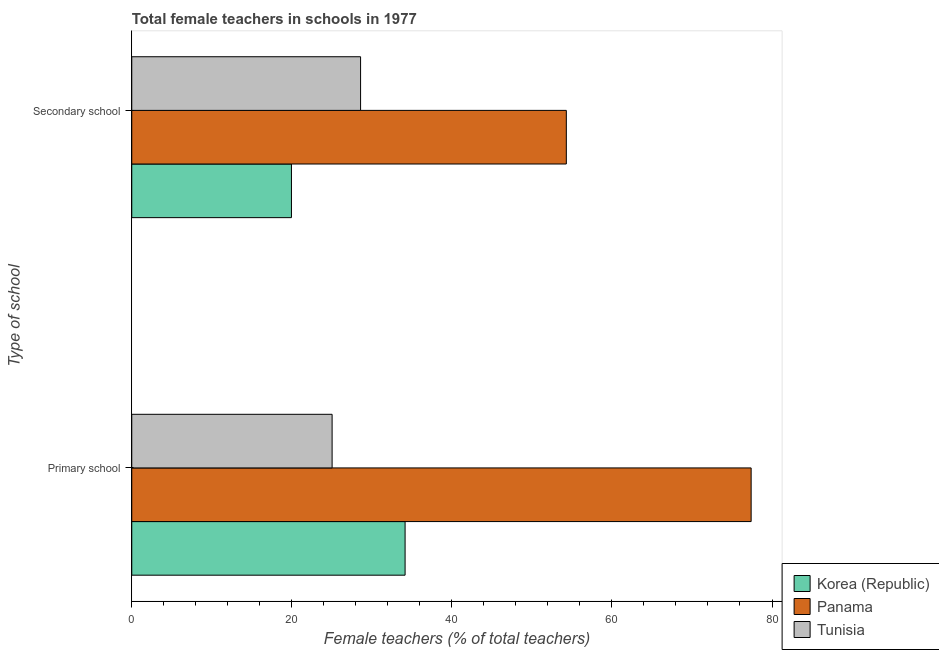How many groups of bars are there?
Provide a short and direct response. 2. Are the number of bars per tick equal to the number of legend labels?
Ensure brevity in your answer.  Yes. What is the label of the 2nd group of bars from the top?
Ensure brevity in your answer.  Primary school. What is the percentage of female teachers in primary schools in Tunisia?
Ensure brevity in your answer.  25.03. Across all countries, what is the maximum percentage of female teachers in primary schools?
Offer a very short reply. 77.39. Across all countries, what is the minimum percentage of female teachers in primary schools?
Ensure brevity in your answer.  25.03. In which country was the percentage of female teachers in primary schools maximum?
Provide a succinct answer. Panama. In which country was the percentage of female teachers in primary schools minimum?
Your response must be concise. Tunisia. What is the total percentage of female teachers in primary schools in the graph?
Your response must be concise. 136.58. What is the difference between the percentage of female teachers in secondary schools in Tunisia and that in Panama?
Keep it short and to the point. -25.71. What is the difference between the percentage of female teachers in secondary schools in Tunisia and the percentage of female teachers in primary schools in Korea (Republic)?
Your response must be concise. -5.56. What is the average percentage of female teachers in primary schools per country?
Ensure brevity in your answer.  45.53. What is the difference between the percentage of female teachers in primary schools and percentage of female teachers in secondary schools in Tunisia?
Ensure brevity in your answer.  -3.56. In how many countries, is the percentage of female teachers in primary schools greater than 8 %?
Make the answer very short. 3. What is the ratio of the percentage of female teachers in secondary schools in Tunisia to that in Korea (Republic)?
Make the answer very short. 1.43. In how many countries, is the percentage of female teachers in secondary schools greater than the average percentage of female teachers in secondary schools taken over all countries?
Provide a short and direct response. 1. What does the 1st bar from the bottom in Primary school represents?
Offer a very short reply. Korea (Republic). What is the difference between two consecutive major ticks on the X-axis?
Keep it short and to the point. 20. Are the values on the major ticks of X-axis written in scientific E-notation?
Give a very brief answer. No. Does the graph contain any zero values?
Ensure brevity in your answer.  No. Does the graph contain grids?
Provide a short and direct response. No. Where does the legend appear in the graph?
Your answer should be very brief. Bottom right. How many legend labels are there?
Ensure brevity in your answer.  3. How are the legend labels stacked?
Offer a very short reply. Vertical. What is the title of the graph?
Your answer should be compact. Total female teachers in schools in 1977. What is the label or title of the X-axis?
Ensure brevity in your answer.  Female teachers (% of total teachers). What is the label or title of the Y-axis?
Provide a short and direct response. Type of school. What is the Female teachers (% of total teachers) of Korea (Republic) in Primary school?
Offer a very short reply. 34.15. What is the Female teachers (% of total teachers) in Panama in Primary school?
Offer a very short reply. 77.39. What is the Female teachers (% of total teachers) in Tunisia in Primary school?
Provide a succinct answer. 25.03. What is the Female teachers (% of total teachers) of Korea (Republic) in Secondary school?
Give a very brief answer. 19.95. What is the Female teachers (% of total teachers) in Panama in Secondary school?
Keep it short and to the point. 54.3. What is the Female teachers (% of total teachers) in Tunisia in Secondary school?
Give a very brief answer. 28.59. Across all Type of school, what is the maximum Female teachers (% of total teachers) of Korea (Republic)?
Offer a very short reply. 34.15. Across all Type of school, what is the maximum Female teachers (% of total teachers) of Panama?
Your answer should be very brief. 77.39. Across all Type of school, what is the maximum Female teachers (% of total teachers) of Tunisia?
Your answer should be very brief. 28.59. Across all Type of school, what is the minimum Female teachers (% of total teachers) in Korea (Republic)?
Keep it short and to the point. 19.95. Across all Type of school, what is the minimum Female teachers (% of total teachers) of Panama?
Ensure brevity in your answer.  54.3. Across all Type of school, what is the minimum Female teachers (% of total teachers) of Tunisia?
Provide a succinct answer. 25.03. What is the total Female teachers (% of total teachers) of Korea (Republic) in the graph?
Offer a very short reply. 54.11. What is the total Female teachers (% of total teachers) in Panama in the graph?
Give a very brief answer. 131.69. What is the total Female teachers (% of total teachers) of Tunisia in the graph?
Provide a succinct answer. 53.62. What is the difference between the Female teachers (% of total teachers) in Korea (Republic) in Primary school and that in Secondary school?
Your response must be concise. 14.2. What is the difference between the Female teachers (% of total teachers) in Panama in Primary school and that in Secondary school?
Ensure brevity in your answer.  23.09. What is the difference between the Female teachers (% of total teachers) of Tunisia in Primary school and that in Secondary school?
Offer a very short reply. -3.56. What is the difference between the Female teachers (% of total teachers) of Korea (Republic) in Primary school and the Female teachers (% of total teachers) of Panama in Secondary school?
Your answer should be very brief. -20.15. What is the difference between the Female teachers (% of total teachers) of Korea (Republic) in Primary school and the Female teachers (% of total teachers) of Tunisia in Secondary school?
Your answer should be very brief. 5.56. What is the difference between the Female teachers (% of total teachers) of Panama in Primary school and the Female teachers (% of total teachers) of Tunisia in Secondary school?
Ensure brevity in your answer.  48.8. What is the average Female teachers (% of total teachers) in Korea (Republic) per Type of school?
Your answer should be very brief. 27.05. What is the average Female teachers (% of total teachers) of Panama per Type of school?
Provide a succinct answer. 65.85. What is the average Female teachers (% of total teachers) in Tunisia per Type of school?
Keep it short and to the point. 26.81. What is the difference between the Female teachers (% of total teachers) in Korea (Republic) and Female teachers (% of total teachers) in Panama in Primary school?
Give a very brief answer. -43.24. What is the difference between the Female teachers (% of total teachers) in Korea (Republic) and Female teachers (% of total teachers) in Tunisia in Primary school?
Keep it short and to the point. 9.12. What is the difference between the Female teachers (% of total teachers) in Panama and Female teachers (% of total teachers) in Tunisia in Primary school?
Your answer should be compact. 52.36. What is the difference between the Female teachers (% of total teachers) of Korea (Republic) and Female teachers (% of total teachers) of Panama in Secondary school?
Offer a very short reply. -34.35. What is the difference between the Female teachers (% of total teachers) of Korea (Republic) and Female teachers (% of total teachers) of Tunisia in Secondary school?
Your answer should be compact. -8.64. What is the difference between the Female teachers (% of total teachers) in Panama and Female teachers (% of total teachers) in Tunisia in Secondary school?
Offer a terse response. 25.71. What is the ratio of the Female teachers (% of total teachers) in Korea (Republic) in Primary school to that in Secondary school?
Keep it short and to the point. 1.71. What is the ratio of the Female teachers (% of total teachers) in Panama in Primary school to that in Secondary school?
Your answer should be very brief. 1.43. What is the ratio of the Female teachers (% of total teachers) of Tunisia in Primary school to that in Secondary school?
Keep it short and to the point. 0.88. What is the difference between the highest and the second highest Female teachers (% of total teachers) of Korea (Republic)?
Offer a terse response. 14.2. What is the difference between the highest and the second highest Female teachers (% of total teachers) of Panama?
Offer a very short reply. 23.09. What is the difference between the highest and the second highest Female teachers (% of total teachers) in Tunisia?
Make the answer very short. 3.56. What is the difference between the highest and the lowest Female teachers (% of total teachers) of Korea (Republic)?
Your answer should be compact. 14.2. What is the difference between the highest and the lowest Female teachers (% of total teachers) in Panama?
Ensure brevity in your answer.  23.09. What is the difference between the highest and the lowest Female teachers (% of total teachers) of Tunisia?
Your answer should be very brief. 3.56. 